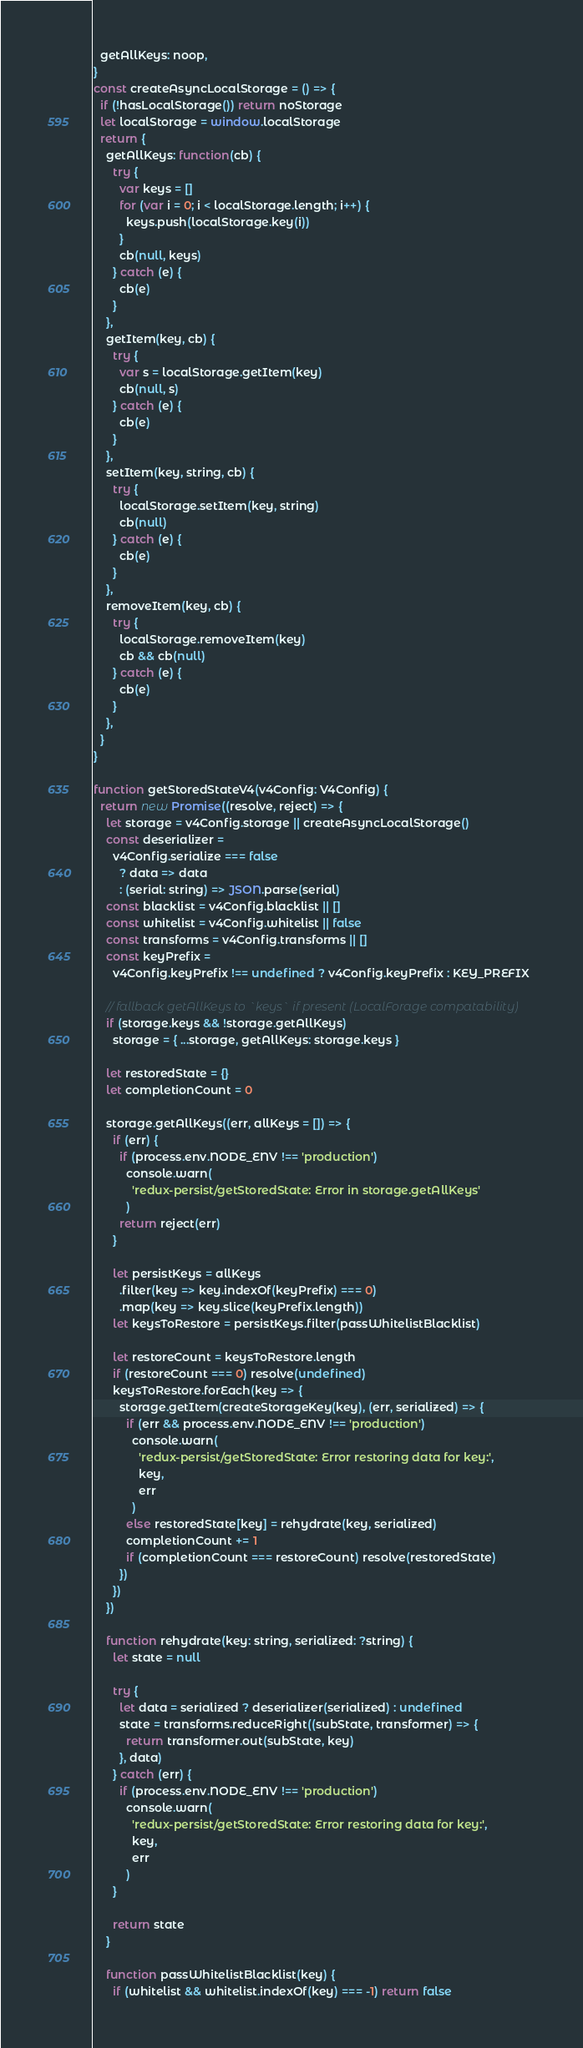Convert code to text. <code><loc_0><loc_0><loc_500><loc_500><_JavaScript_>  getAllKeys: noop,
}
const createAsyncLocalStorage = () => {
  if (!hasLocalStorage()) return noStorage
  let localStorage = window.localStorage
  return {
    getAllKeys: function(cb) {
      try {
        var keys = []
        for (var i = 0; i < localStorage.length; i++) {
          keys.push(localStorage.key(i))
        }
        cb(null, keys)
      } catch (e) {
        cb(e)
      }
    },
    getItem(key, cb) {
      try {
        var s = localStorage.getItem(key)
        cb(null, s)
      } catch (e) {
        cb(e)
      }
    },
    setItem(key, string, cb) {
      try {
        localStorage.setItem(key, string)
        cb(null)
      } catch (e) {
        cb(e)
      }
    },
    removeItem(key, cb) {
      try {
        localStorage.removeItem(key)
        cb && cb(null)
      } catch (e) {
        cb(e)
      }
    },
  }
}

function getStoredStateV4(v4Config: V4Config) {
  return new Promise((resolve, reject) => {
    let storage = v4Config.storage || createAsyncLocalStorage()
    const deserializer =
      v4Config.serialize === false
        ? data => data
        : (serial: string) => JSON.parse(serial)
    const blacklist = v4Config.blacklist || []
    const whitelist = v4Config.whitelist || false
    const transforms = v4Config.transforms || []
    const keyPrefix =
      v4Config.keyPrefix !== undefined ? v4Config.keyPrefix : KEY_PREFIX

    // fallback getAllKeys to `keys` if present (LocalForage compatability)
    if (storage.keys && !storage.getAllKeys)
      storage = { ...storage, getAllKeys: storage.keys }

    let restoredState = {}
    let completionCount = 0

    storage.getAllKeys((err, allKeys = []) => {
      if (err) {
        if (process.env.NODE_ENV !== 'production')
          console.warn(
            'redux-persist/getStoredState: Error in storage.getAllKeys'
          )
        return reject(err)
      }

      let persistKeys = allKeys
        .filter(key => key.indexOf(keyPrefix) === 0)
        .map(key => key.slice(keyPrefix.length))
      let keysToRestore = persistKeys.filter(passWhitelistBlacklist)

      let restoreCount = keysToRestore.length
      if (restoreCount === 0) resolve(undefined)
      keysToRestore.forEach(key => {
        storage.getItem(createStorageKey(key), (err, serialized) => {
          if (err && process.env.NODE_ENV !== 'production')
            console.warn(
              'redux-persist/getStoredState: Error restoring data for key:',
              key,
              err
            )
          else restoredState[key] = rehydrate(key, serialized)
          completionCount += 1
          if (completionCount === restoreCount) resolve(restoredState)
        })
      })
    })

    function rehydrate(key: string, serialized: ?string) {
      let state = null

      try {
        let data = serialized ? deserializer(serialized) : undefined
        state = transforms.reduceRight((subState, transformer) => {
          return transformer.out(subState, key)
        }, data)
      } catch (err) {
        if (process.env.NODE_ENV !== 'production')
          console.warn(
            'redux-persist/getStoredState: Error restoring data for key:',
            key,
            err
          )
      }

      return state
    }

    function passWhitelistBlacklist(key) {
      if (whitelist && whitelist.indexOf(key) === -1) return false</code> 